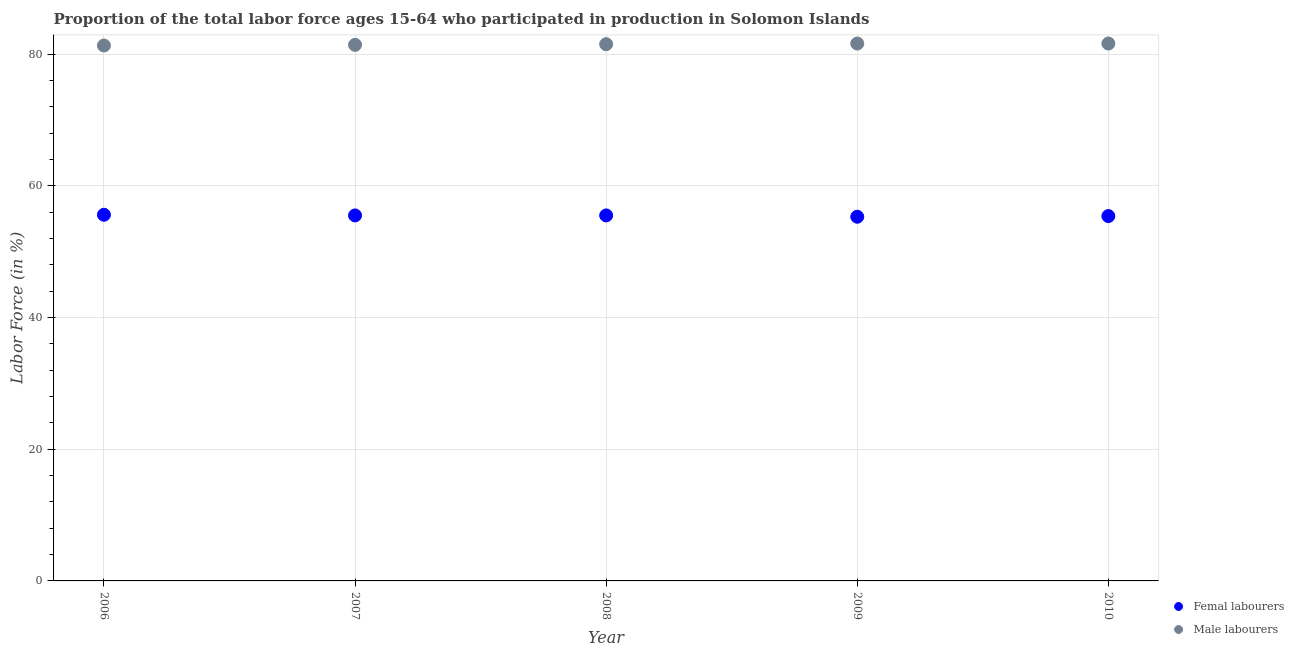Is the number of dotlines equal to the number of legend labels?
Offer a very short reply. Yes. What is the percentage of female labor force in 2006?
Your response must be concise. 55.6. Across all years, what is the maximum percentage of male labour force?
Give a very brief answer. 81.6. Across all years, what is the minimum percentage of male labour force?
Give a very brief answer. 81.3. What is the total percentage of female labor force in the graph?
Offer a very short reply. 277.3. What is the difference between the percentage of male labour force in 2006 and that in 2010?
Offer a terse response. -0.3. What is the difference between the percentage of male labour force in 2010 and the percentage of female labor force in 2006?
Your answer should be compact. 26. What is the average percentage of female labor force per year?
Make the answer very short. 55.46. In the year 2006, what is the difference between the percentage of male labour force and percentage of female labor force?
Make the answer very short. 25.7. In how many years, is the percentage of female labor force greater than 56 %?
Make the answer very short. 0. What is the ratio of the percentage of male labour force in 2006 to that in 2007?
Ensure brevity in your answer.  1. What is the difference between the highest and the second highest percentage of female labor force?
Your answer should be compact. 0.1. What is the difference between the highest and the lowest percentage of female labor force?
Keep it short and to the point. 0.3. In how many years, is the percentage of male labour force greater than the average percentage of male labour force taken over all years?
Your answer should be compact. 3. Is the sum of the percentage of female labor force in 2008 and 2009 greater than the maximum percentage of male labour force across all years?
Keep it short and to the point. Yes. Is the percentage of female labor force strictly greater than the percentage of male labour force over the years?
Your response must be concise. No. How many dotlines are there?
Offer a very short reply. 2. Are the values on the major ticks of Y-axis written in scientific E-notation?
Provide a short and direct response. No. Does the graph contain grids?
Provide a succinct answer. Yes. What is the title of the graph?
Offer a very short reply. Proportion of the total labor force ages 15-64 who participated in production in Solomon Islands. What is the label or title of the Y-axis?
Keep it short and to the point. Labor Force (in %). What is the Labor Force (in %) in Femal labourers in 2006?
Make the answer very short. 55.6. What is the Labor Force (in %) in Male labourers in 2006?
Provide a short and direct response. 81.3. What is the Labor Force (in %) in Femal labourers in 2007?
Give a very brief answer. 55.5. What is the Labor Force (in %) of Male labourers in 2007?
Offer a very short reply. 81.4. What is the Labor Force (in %) in Femal labourers in 2008?
Give a very brief answer. 55.5. What is the Labor Force (in %) of Male labourers in 2008?
Make the answer very short. 81.5. What is the Labor Force (in %) in Femal labourers in 2009?
Ensure brevity in your answer.  55.3. What is the Labor Force (in %) of Male labourers in 2009?
Give a very brief answer. 81.6. What is the Labor Force (in %) of Femal labourers in 2010?
Offer a terse response. 55.4. What is the Labor Force (in %) of Male labourers in 2010?
Ensure brevity in your answer.  81.6. Across all years, what is the maximum Labor Force (in %) in Femal labourers?
Make the answer very short. 55.6. Across all years, what is the maximum Labor Force (in %) in Male labourers?
Give a very brief answer. 81.6. Across all years, what is the minimum Labor Force (in %) in Femal labourers?
Provide a short and direct response. 55.3. Across all years, what is the minimum Labor Force (in %) of Male labourers?
Give a very brief answer. 81.3. What is the total Labor Force (in %) of Femal labourers in the graph?
Ensure brevity in your answer.  277.3. What is the total Labor Force (in %) in Male labourers in the graph?
Give a very brief answer. 407.4. What is the difference between the Labor Force (in %) of Male labourers in 2006 and that in 2007?
Your answer should be compact. -0.1. What is the difference between the Labor Force (in %) in Male labourers in 2006 and that in 2008?
Provide a succinct answer. -0.2. What is the difference between the Labor Force (in %) in Femal labourers in 2006 and that in 2009?
Your answer should be compact. 0.3. What is the difference between the Labor Force (in %) of Male labourers in 2006 and that in 2010?
Provide a short and direct response. -0.3. What is the difference between the Labor Force (in %) of Femal labourers in 2007 and that in 2008?
Keep it short and to the point. 0. What is the difference between the Labor Force (in %) of Femal labourers in 2007 and that in 2009?
Give a very brief answer. 0.2. What is the difference between the Labor Force (in %) in Male labourers in 2007 and that in 2009?
Offer a terse response. -0.2. What is the difference between the Labor Force (in %) in Male labourers in 2007 and that in 2010?
Your response must be concise. -0.2. What is the difference between the Labor Force (in %) in Male labourers in 2008 and that in 2010?
Keep it short and to the point. -0.1. What is the difference between the Labor Force (in %) in Femal labourers in 2006 and the Labor Force (in %) in Male labourers in 2007?
Offer a terse response. -25.8. What is the difference between the Labor Force (in %) in Femal labourers in 2006 and the Labor Force (in %) in Male labourers in 2008?
Keep it short and to the point. -25.9. What is the difference between the Labor Force (in %) of Femal labourers in 2006 and the Labor Force (in %) of Male labourers in 2009?
Your response must be concise. -26. What is the difference between the Labor Force (in %) in Femal labourers in 2006 and the Labor Force (in %) in Male labourers in 2010?
Ensure brevity in your answer.  -26. What is the difference between the Labor Force (in %) in Femal labourers in 2007 and the Labor Force (in %) in Male labourers in 2009?
Your answer should be very brief. -26.1. What is the difference between the Labor Force (in %) in Femal labourers in 2007 and the Labor Force (in %) in Male labourers in 2010?
Your answer should be compact. -26.1. What is the difference between the Labor Force (in %) in Femal labourers in 2008 and the Labor Force (in %) in Male labourers in 2009?
Your response must be concise. -26.1. What is the difference between the Labor Force (in %) in Femal labourers in 2008 and the Labor Force (in %) in Male labourers in 2010?
Your answer should be compact. -26.1. What is the difference between the Labor Force (in %) of Femal labourers in 2009 and the Labor Force (in %) of Male labourers in 2010?
Ensure brevity in your answer.  -26.3. What is the average Labor Force (in %) in Femal labourers per year?
Offer a very short reply. 55.46. What is the average Labor Force (in %) of Male labourers per year?
Your answer should be compact. 81.48. In the year 2006, what is the difference between the Labor Force (in %) in Femal labourers and Labor Force (in %) in Male labourers?
Offer a terse response. -25.7. In the year 2007, what is the difference between the Labor Force (in %) in Femal labourers and Labor Force (in %) in Male labourers?
Offer a very short reply. -25.9. In the year 2009, what is the difference between the Labor Force (in %) of Femal labourers and Labor Force (in %) of Male labourers?
Your response must be concise. -26.3. In the year 2010, what is the difference between the Labor Force (in %) in Femal labourers and Labor Force (in %) in Male labourers?
Give a very brief answer. -26.2. What is the ratio of the Labor Force (in %) of Male labourers in 2006 to that in 2007?
Your response must be concise. 1. What is the ratio of the Labor Force (in %) in Male labourers in 2006 to that in 2008?
Your answer should be compact. 1. What is the ratio of the Labor Force (in %) in Femal labourers in 2006 to that in 2009?
Keep it short and to the point. 1.01. What is the ratio of the Labor Force (in %) of Male labourers in 2006 to that in 2009?
Your response must be concise. 1. What is the ratio of the Labor Force (in %) of Femal labourers in 2006 to that in 2010?
Provide a succinct answer. 1. What is the ratio of the Labor Force (in %) in Male labourers in 2007 to that in 2008?
Keep it short and to the point. 1. What is the ratio of the Labor Force (in %) in Femal labourers in 2007 to that in 2009?
Ensure brevity in your answer.  1. What is the ratio of the Labor Force (in %) in Male labourers in 2007 to that in 2009?
Offer a very short reply. 1. What is the ratio of the Labor Force (in %) of Femal labourers in 2007 to that in 2010?
Provide a short and direct response. 1. What is the ratio of the Labor Force (in %) of Femal labourers in 2008 to that in 2009?
Your response must be concise. 1. What is the ratio of the Labor Force (in %) in Male labourers in 2008 to that in 2009?
Give a very brief answer. 1. What is the ratio of the Labor Force (in %) of Femal labourers in 2008 to that in 2010?
Ensure brevity in your answer.  1. What is the ratio of the Labor Force (in %) of Male labourers in 2008 to that in 2010?
Ensure brevity in your answer.  1. What is the ratio of the Labor Force (in %) of Femal labourers in 2009 to that in 2010?
Provide a short and direct response. 1. What is the ratio of the Labor Force (in %) of Male labourers in 2009 to that in 2010?
Your answer should be very brief. 1. What is the difference between the highest and the lowest Labor Force (in %) of Femal labourers?
Provide a succinct answer. 0.3. What is the difference between the highest and the lowest Labor Force (in %) of Male labourers?
Make the answer very short. 0.3. 